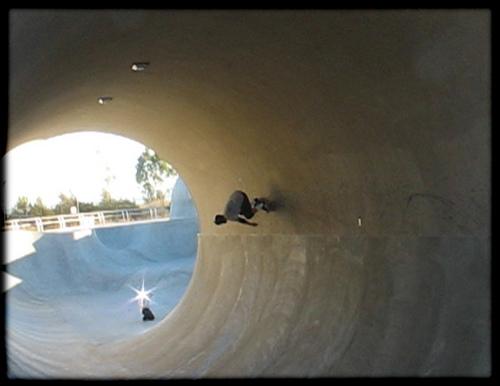Is it daytime?
Concise answer only. Yes. Where is this picture taken?
Write a very short answer. Skate park. What is the man doing?
Write a very short answer. Skateboarding. 